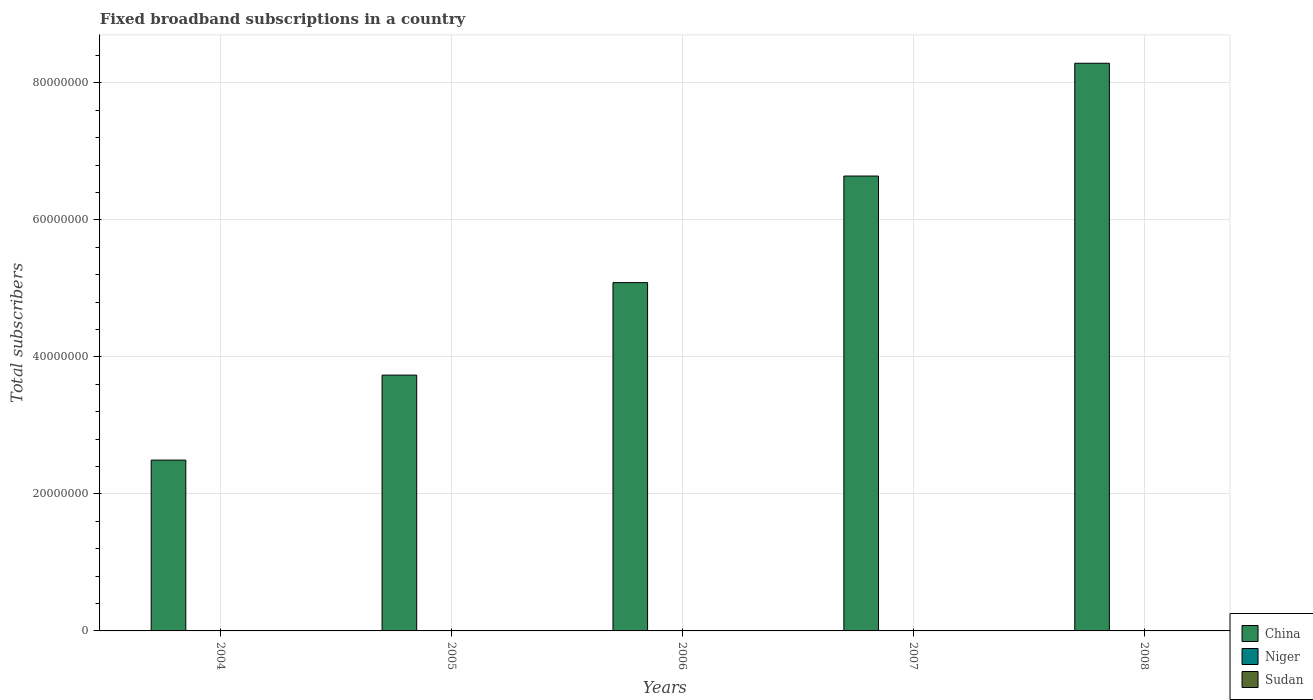How many different coloured bars are there?
Offer a terse response. 3. How many groups of bars are there?
Provide a short and direct response. 5. Are the number of bars per tick equal to the number of legend labels?
Your answer should be very brief. Yes. Are the number of bars on each tick of the X-axis equal?
Make the answer very short. Yes. How many bars are there on the 5th tick from the left?
Offer a very short reply. 3. What is the label of the 5th group of bars from the left?
Offer a terse response. 2008. What is the number of broadband subscriptions in Sudan in 2005?
Give a very brief answer. 1269. Across all years, what is the maximum number of broadband subscriptions in Niger?
Ensure brevity in your answer.  617. Across all years, what is the minimum number of broadband subscriptions in Niger?
Provide a short and direct response. 77. In which year was the number of broadband subscriptions in China minimum?
Provide a succinct answer. 2004. What is the total number of broadband subscriptions in China in the graph?
Make the answer very short. 2.62e+08. What is the difference between the number of broadband subscriptions in Sudan in 2006 and that in 2007?
Your answer should be compact. -4.04e+04. What is the difference between the number of broadband subscriptions in China in 2007 and the number of broadband subscriptions in Niger in 2004?
Provide a succinct answer. 6.64e+07. What is the average number of broadband subscriptions in Sudan per year?
Keep it short and to the point. 1.83e+04. In the year 2007, what is the difference between the number of broadband subscriptions in China and number of broadband subscriptions in Sudan?
Make the answer very short. 6.64e+07. In how many years, is the number of broadband subscriptions in Sudan greater than 36000000?
Offer a terse response. 0. What is the ratio of the number of broadband subscriptions in Sudan in 2004 to that in 2006?
Provide a succinct answer. 0.38. Is the difference between the number of broadband subscriptions in China in 2004 and 2005 greater than the difference between the number of broadband subscriptions in Sudan in 2004 and 2005?
Ensure brevity in your answer.  No. What is the difference between the highest and the second highest number of broadband subscriptions in Niger?
Offer a very short reply. 135. What is the difference between the highest and the lowest number of broadband subscriptions in China?
Offer a terse response. 5.79e+07. Is the sum of the number of broadband subscriptions in China in 2006 and 2007 greater than the maximum number of broadband subscriptions in Sudan across all years?
Offer a terse response. Yes. What does the 2nd bar from the left in 2008 represents?
Offer a terse response. Niger. What does the 1st bar from the right in 2006 represents?
Provide a succinct answer. Sudan. Is it the case that in every year, the sum of the number of broadband subscriptions in Niger and number of broadband subscriptions in Sudan is greater than the number of broadband subscriptions in China?
Provide a short and direct response. No. What is the difference between two consecutive major ticks on the Y-axis?
Offer a very short reply. 2.00e+07. Does the graph contain grids?
Offer a very short reply. Yes. Where does the legend appear in the graph?
Your response must be concise. Bottom right. What is the title of the graph?
Make the answer very short. Fixed broadband subscriptions in a country. What is the label or title of the X-axis?
Give a very brief answer. Years. What is the label or title of the Y-axis?
Provide a succinct answer. Total subscribers. What is the Total subscribers of China in 2004?
Offer a terse response. 2.49e+07. What is the Total subscribers in Sudan in 2004?
Ensure brevity in your answer.  793. What is the Total subscribers in China in 2005?
Offer a very short reply. 3.74e+07. What is the Total subscribers in Niger in 2005?
Offer a very short reply. 212. What is the Total subscribers of Sudan in 2005?
Keep it short and to the point. 1269. What is the Total subscribers of China in 2006?
Provide a short and direct response. 5.09e+07. What is the Total subscribers in Niger in 2006?
Provide a succinct answer. 347. What is the Total subscribers of Sudan in 2006?
Ensure brevity in your answer.  2065. What is the Total subscribers in China in 2007?
Your response must be concise. 6.64e+07. What is the Total subscribers of Niger in 2007?
Your answer should be very brief. 482. What is the Total subscribers of Sudan in 2007?
Ensure brevity in your answer.  4.25e+04. What is the Total subscribers of China in 2008?
Provide a short and direct response. 8.29e+07. What is the Total subscribers of Niger in 2008?
Make the answer very short. 617. What is the Total subscribers in Sudan in 2008?
Make the answer very short. 4.46e+04. Across all years, what is the maximum Total subscribers of China?
Keep it short and to the point. 8.29e+07. Across all years, what is the maximum Total subscribers of Niger?
Your answer should be compact. 617. Across all years, what is the maximum Total subscribers of Sudan?
Provide a short and direct response. 4.46e+04. Across all years, what is the minimum Total subscribers of China?
Offer a very short reply. 2.49e+07. Across all years, what is the minimum Total subscribers of Sudan?
Your response must be concise. 793. What is the total Total subscribers in China in the graph?
Give a very brief answer. 2.62e+08. What is the total Total subscribers of Niger in the graph?
Give a very brief answer. 1735. What is the total Total subscribers of Sudan in the graph?
Your answer should be very brief. 9.13e+04. What is the difference between the Total subscribers of China in 2004 and that in 2005?
Make the answer very short. -1.24e+07. What is the difference between the Total subscribers of Niger in 2004 and that in 2005?
Provide a succinct answer. -135. What is the difference between the Total subscribers in Sudan in 2004 and that in 2005?
Your answer should be very brief. -476. What is the difference between the Total subscribers of China in 2004 and that in 2006?
Your answer should be very brief. -2.59e+07. What is the difference between the Total subscribers in Niger in 2004 and that in 2006?
Keep it short and to the point. -270. What is the difference between the Total subscribers of Sudan in 2004 and that in 2006?
Make the answer very short. -1272. What is the difference between the Total subscribers of China in 2004 and that in 2007?
Offer a very short reply. -4.15e+07. What is the difference between the Total subscribers of Niger in 2004 and that in 2007?
Give a very brief answer. -405. What is the difference between the Total subscribers in Sudan in 2004 and that in 2007?
Provide a short and direct response. -4.17e+04. What is the difference between the Total subscribers in China in 2004 and that in 2008?
Offer a very short reply. -5.79e+07. What is the difference between the Total subscribers in Niger in 2004 and that in 2008?
Offer a very short reply. -540. What is the difference between the Total subscribers in Sudan in 2004 and that in 2008?
Provide a short and direct response. -4.38e+04. What is the difference between the Total subscribers in China in 2005 and that in 2006?
Ensure brevity in your answer.  -1.35e+07. What is the difference between the Total subscribers in Niger in 2005 and that in 2006?
Provide a succinct answer. -135. What is the difference between the Total subscribers in Sudan in 2005 and that in 2006?
Offer a very short reply. -796. What is the difference between the Total subscribers in China in 2005 and that in 2007?
Make the answer very short. -2.91e+07. What is the difference between the Total subscribers in Niger in 2005 and that in 2007?
Provide a succinct answer. -270. What is the difference between the Total subscribers of Sudan in 2005 and that in 2007?
Make the answer very short. -4.12e+04. What is the difference between the Total subscribers in China in 2005 and that in 2008?
Your response must be concise. -4.55e+07. What is the difference between the Total subscribers of Niger in 2005 and that in 2008?
Make the answer very short. -405. What is the difference between the Total subscribers of Sudan in 2005 and that in 2008?
Your response must be concise. -4.34e+04. What is the difference between the Total subscribers in China in 2006 and that in 2007?
Your answer should be compact. -1.56e+07. What is the difference between the Total subscribers in Niger in 2006 and that in 2007?
Your response must be concise. -135. What is the difference between the Total subscribers of Sudan in 2006 and that in 2007?
Your response must be concise. -4.04e+04. What is the difference between the Total subscribers of China in 2006 and that in 2008?
Your answer should be very brief. -3.20e+07. What is the difference between the Total subscribers in Niger in 2006 and that in 2008?
Your response must be concise. -270. What is the difference between the Total subscribers in Sudan in 2006 and that in 2008?
Offer a terse response. -4.26e+04. What is the difference between the Total subscribers of China in 2007 and that in 2008?
Ensure brevity in your answer.  -1.65e+07. What is the difference between the Total subscribers of Niger in 2007 and that in 2008?
Provide a short and direct response. -135. What is the difference between the Total subscribers of Sudan in 2007 and that in 2008?
Your answer should be very brief. -2125. What is the difference between the Total subscribers in China in 2004 and the Total subscribers in Niger in 2005?
Offer a terse response. 2.49e+07. What is the difference between the Total subscribers of China in 2004 and the Total subscribers of Sudan in 2005?
Offer a very short reply. 2.49e+07. What is the difference between the Total subscribers in Niger in 2004 and the Total subscribers in Sudan in 2005?
Give a very brief answer. -1192. What is the difference between the Total subscribers in China in 2004 and the Total subscribers in Niger in 2006?
Make the answer very short. 2.49e+07. What is the difference between the Total subscribers of China in 2004 and the Total subscribers of Sudan in 2006?
Your answer should be very brief. 2.49e+07. What is the difference between the Total subscribers of Niger in 2004 and the Total subscribers of Sudan in 2006?
Give a very brief answer. -1988. What is the difference between the Total subscribers of China in 2004 and the Total subscribers of Niger in 2007?
Ensure brevity in your answer.  2.49e+07. What is the difference between the Total subscribers of China in 2004 and the Total subscribers of Sudan in 2007?
Your response must be concise. 2.49e+07. What is the difference between the Total subscribers in Niger in 2004 and the Total subscribers in Sudan in 2007?
Provide a short and direct response. -4.24e+04. What is the difference between the Total subscribers in China in 2004 and the Total subscribers in Niger in 2008?
Offer a very short reply. 2.49e+07. What is the difference between the Total subscribers of China in 2004 and the Total subscribers of Sudan in 2008?
Your answer should be very brief. 2.49e+07. What is the difference between the Total subscribers of Niger in 2004 and the Total subscribers of Sudan in 2008?
Keep it short and to the point. -4.45e+04. What is the difference between the Total subscribers of China in 2005 and the Total subscribers of Niger in 2006?
Your response must be concise. 3.73e+07. What is the difference between the Total subscribers of China in 2005 and the Total subscribers of Sudan in 2006?
Keep it short and to the point. 3.73e+07. What is the difference between the Total subscribers of Niger in 2005 and the Total subscribers of Sudan in 2006?
Your answer should be very brief. -1853. What is the difference between the Total subscribers in China in 2005 and the Total subscribers in Niger in 2007?
Your answer should be very brief. 3.73e+07. What is the difference between the Total subscribers in China in 2005 and the Total subscribers in Sudan in 2007?
Your answer should be compact. 3.73e+07. What is the difference between the Total subscribers in Niger in 2005 and the Total subscribers in Sudan in 2007?
Your answer should be compact. -4.23e+04. What is the difference between the Total subscribers of China in 2005 and the Total subscribers of Niger in 2008?
Provide a short and direct response. 3.73e+07. What is the difference between the Total subscribers of China in 2005 and the Total subscribers of Sudan in 2008?
Offer a terse response. 3.73e+07. What is the difference between the Total subscribers of Niger in 2005 and the Total subscribers of Sudan in 2008?
Ensure brevity in your answer.  -4.44e+04. What is the difference between the Total subscribers in China in 2006 and the Total subscribers in Niger in 2007?
Give a very brief answer. 5.09e+07. What is the difference between the Total subscribers of China in 2006 and the Total subscribers of Sudan in 2007?
Provide a succinct answer. 5.08e+07. What is the difference between the Total subscribers in Niger in 2006 and the Total subscribers in Sudan in 2007?
Ensure brevity in your answer.  -4.22e+04. What is the difference between the Total subscribers in China in 2006 and the Total subscribers in Niger in 2008?
Your answer should be very brief. 5.09e+07. What is the difference between the Total subscribers in China in 2006 and the Total subscribers in Sudan in 2008?
Provide a succinct answer. 5.08e+07. What is the difference between the Total subscribers in Niger in 2006 and the Total subscribers in Sudan in 2008?
Provide a succinct answer. -4.43e+04. What is the difference between the Total subscribers of China in 2007 and the Total subscribers of Niger in 2008?
Ensure brevity in your answer.  6.64e+07. What is the difference between the Total subscribers in China in 2007 and the Total subscribers in Sudan in 2008?
Your answer should be compact. 6.64e+07. What is the difference between the Total subscribers in Niger in 2007 and the Total subscribers in Sudan in 2008?
Offer a terse response. -4.41e+04. What is the average Total subscribers in China per year?
Your answer should be compact. 5.25e+07. What is the average Total subscribers in Niger per year?
Ensure brevity in your answer.  347. What is the average Total subscribers of Sudan per year?
Offer a very short reply. 1.83e+04. In the year 2004, what is the difference between the Total subscribers in China and Total subscribers in Niger?
Offer a terse response. 2.49e+07. In the year 2004, what is the difference between the Total subscribers in China and Total subscribers in Sudan?
Give a very brief answer. 2.49e+07. In the year 2004, what is the difference between the Total subscribers of Niger and Total subscribers of Sudan?
Ensure brevity in your answer.  -716. In the year 2005, what is the difference between the Total subscribers of China and Total subscribers of Niger?
Your answer should be compact. 3.73e+07. In the year 2005, what is the difference between the Total subscribers in China and Total subscribers in Sudan?
Give a very brief answer. 3.73e+07. In the year 2005, what is the difference between the Total subscribers of Niger and Total subscribers of Sudan?
Ensure brevity in your answer.  -1057. In the year 2006, what is the difference between the Total subscribers of China and Total subscribers of Niger?
Your answer should be very brief. 5.09e+07. In the year 2006, what is the difference between the Total subscribers in China and Total subscribers in Sudan?
Give a very brief answer. 5.09e+07. In the year 2006, what is the difference between the Total subscribers of Niger and Total subscribers of Sudan?
Make the answer very short. -1718. In the year 2007, what is the difference between the Total subscribers in China and Total subscribers in Niger?
Give a very brief answer. 6.64e+07. In the year 2007, what is the difference between the Total subscribers in China and Total subscribers in Sudan?
Ensure brevity in your answer.  6.64e+07. In the year 2007, what is the difference between the Total subscribers in Niger and Total subscribers in Sudan?
Provide a succinct answer. -4.20e+04. In the year 2008, what is the difference between the Total subscribers of China and Total subscribers of Niger?
Ensure brevity in your answer.  8.29e+07. In the year 2008, what is the difference between the Total subscribers in China and Total subscribers in Sudan?
Provide a short and direct response. 8.28e+07. In the year 2008, what is the difference between the Total subscribers in Niger and Total subscribers in Sudan?
Provide a succinct answer. -4.40e+04. What is the ratio of the Total subscribers in China in 2004 to that in 2005?
Make the answer very short. 0.67. What is the ratio of the Total subscribers of Niger in 2004 to that in 2005?
Offer a terse response. 0.36. What is the ratio of the Total subscribers in Sudan in 2004 to that in 2005?
Ensure brevity in your answer.  0.62. What is the ratio of the Total subscribers of China in 2004 to that in 2006?
Offer a terse response. 0.49. What is the ratio of the Total subscribers in Niger in 2004 to that in 2006?
Your response must be concise. 0.22. What is the ratio of the Total subscribers of Sudan in 2004 to that in 2006?
Keep it short and to the point. 0.38. What is the ratio of the Total subscribers of China in 2004 to that in 2007?
Your answer should be very brief. 0.38. What is the ratio of the Total subscribers in Niger in 2004 to that in 2007?
Your answer should be very brief. 0.16. What is the ratio of the Total subscribers in Sudan in 2004 to that in 2007?
Your answer should be compact. 0.02. What is the ratio of the Total subscribers of China in 2004 to that in 2008?
Your response must be concise. 0.3. What is the ratio of the Total subscribers of Niger in 2004 to that in 2008?
Keep it short and to the point. 0.12. What is the ratio of the Total subscribers of Sudan in 2004 to that in 2008?
Offer a very short reply. 0.02. What is the ratio of the Total subscribers in China in 2005 to that in 2006?
Your answer should be very brief. 0.73. What is the ratio of the Total subscribers in Niger in 2005 to that in 2006?
Your answer should be very brief. 0.61. What is the ratio of the Total subscribers of Sudan in 2005 to that in 2006?
Your response must be concise. 0.61. What is the ratio of the Total subscribers of China in 2005 to that in 2007?
Your answer should be very brief. 0.56. What is the ratio of the Total subscribers of Niger in 2005 to that in 2007?
Your answer should be very brief. 0.44. What is the ratio of the Total subscribers of Sudan in 2005 to that in 2007?
Make the answer very short. 0.03. What is the ratio of the Total subscribers of China in 2005 to that in 2008?
Ensure brevity in your answer.  0.45. What is the ratio of the Total subscribers in Niger in 2005 to that in 2008?
Provide a succinct answer. 0.34. What is the ratio of the Total subscribers in Sudan in 2005 to that in 2008?
Your answer should be compact. 0.03. What is the ratio of the Total subscribers of China in 2006 to that in 2007?
Offer a terse response. 0.77. What is the ratio of the Total subscribers in Niger in 2006 to that in 2007?
Keep it short and to the point. 0.72. What is the ratio of the Total subscribers in Sudan in 2006 to that in 2007?
Make the answer very short. 0.05. What is the ratio of the Total subscribers in China in 2006 to that in 2008?
Give a very brief answer. 0.61. What is the ratio of the Total subscribers of Niger in 2006 to that in 2008?
Offer a terse response. 0.56. What is the ratio of the Total subscribers in Sudan in 2006 to that in 2008?
Provide a succinct answer. 0.05. What is the ratio of the Total subscribers of China in 2007 to that in 2008?
Make the answer very short. 0.8. What is the ratio of the Total subscribers in Niger in 2007 to that in 2008?
Offer a terse response. 0.78. What is the difference between the highest and the second highest Total subscribers of China?
Offer a very short reply. 1.65e+07. What is the difference between the highest and the second highest Total subscribers of Niger?
Provide a succinct answer. 135. What is the difference between the highest and the second highest Total subscribers of Sudan?
Provide a succinct answer. 2125. What is the difference between the highest and the lowest Total subscribers in China?
Make the answer very short. 5.79e+07. What is the difference between the highest and the lowest Total subscribers in Niger?
Offer a very short reply. 540. What is the difference between the highest and the lowest Total subscribers in Sudan?
Keep it short and to the point. 4.38e+04. 